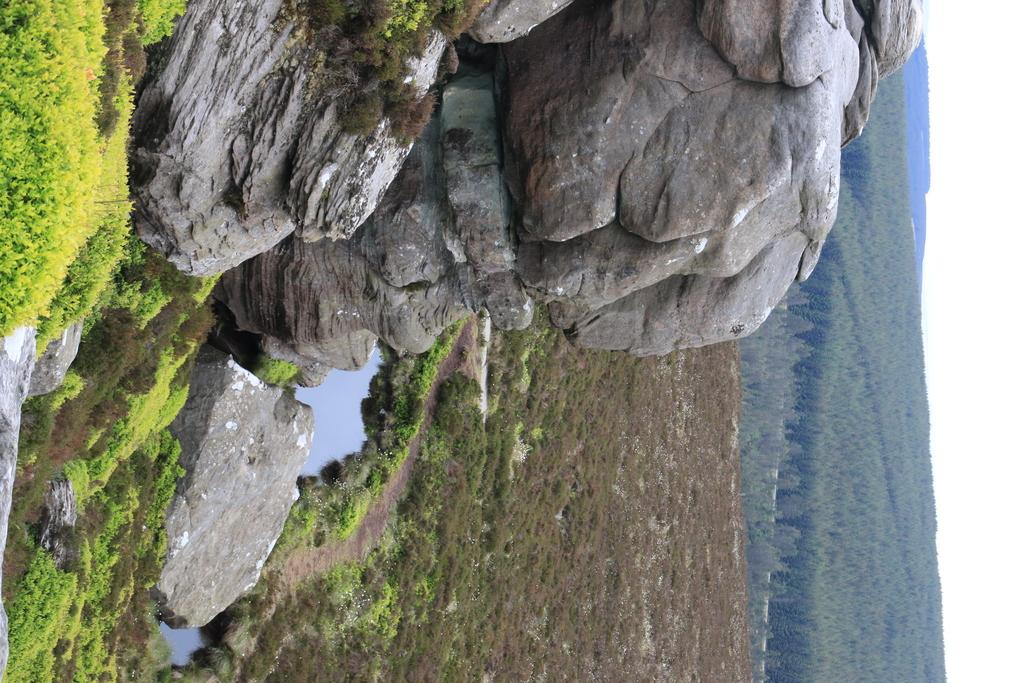What type of natural elements can be seen in the image? There are rocks, trees, plants, and water visible in the image. What is visible in the background of the image? There are mountains and trees in the background of the image. What type of bone can be seen in the image? There is no bone present in the image; it features natural elements such as rocks, trees, plants, and water. 